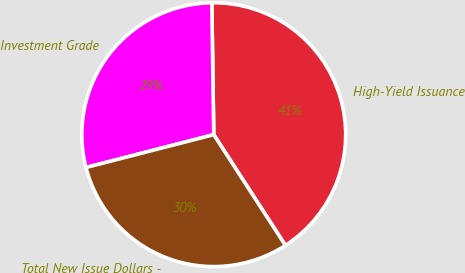<chart> <loc_0><loc_0><loc_500><loc_500><pie_chart><fcel>High-Yield Issuance<fcel>Investment Grade<fcel>Total New Issue Dollars -<nl><fcel>41.1%<fcel>28.77%<fcel>30.14%<nl></chart> 